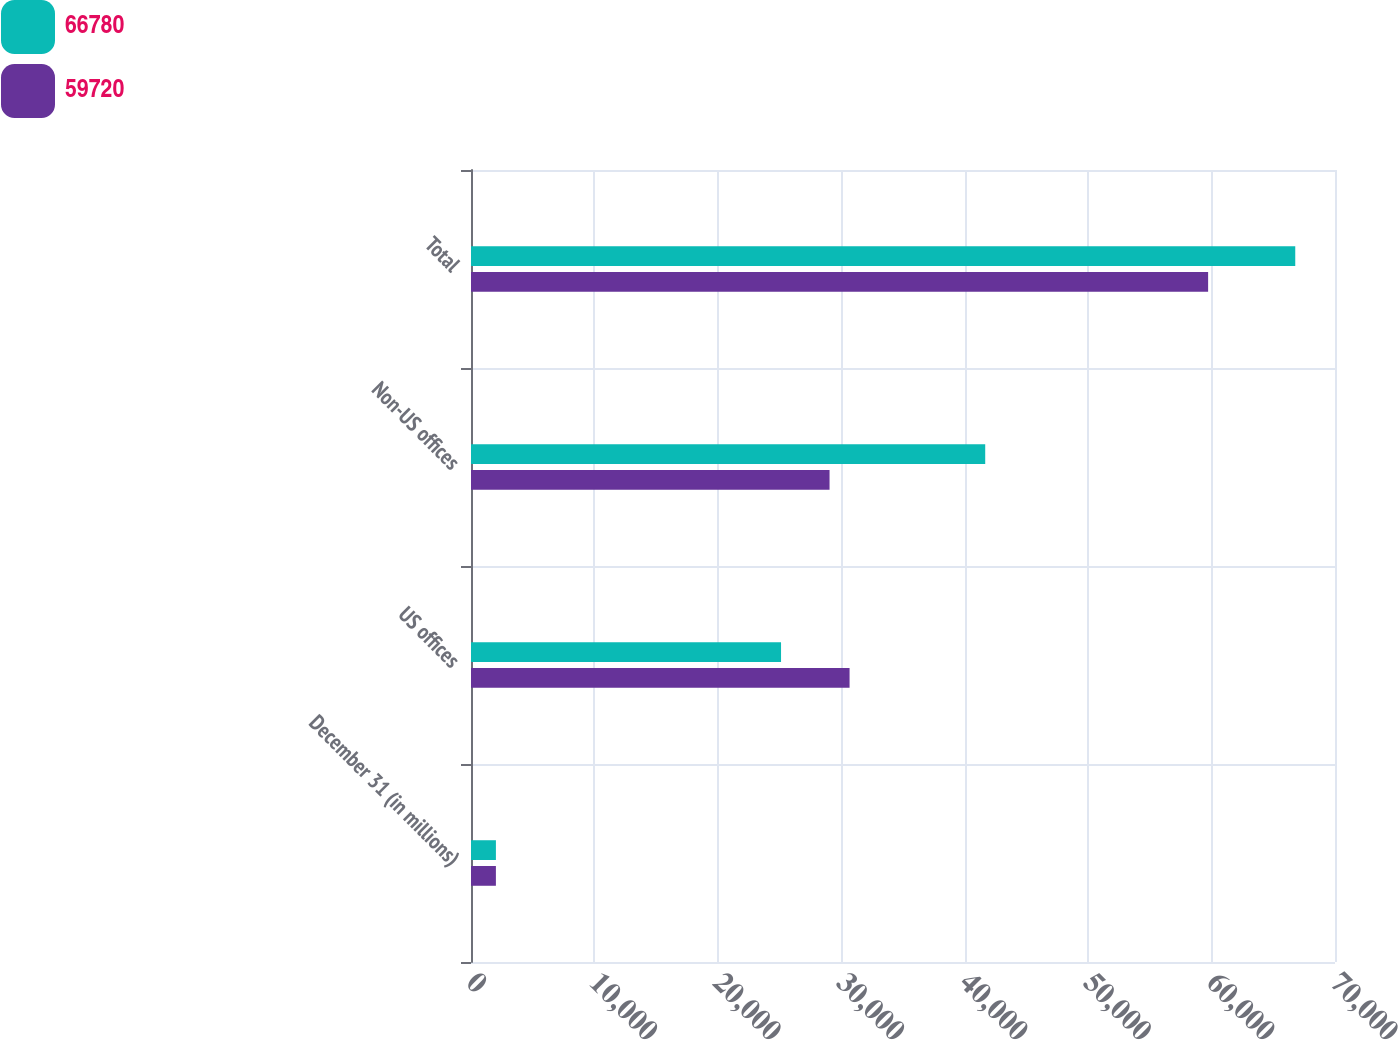Convert chart to OTSL. <chart><loc_0><loc_0><loc_500><loc_500><stacked_bar_chart><ecel><fcel>December 31 (in millions)<fcel>US offices<fcel>Non-US offices<fcel>Total<nl><fcel>66780<fcel>2018<fcel>25119<fcel>41661<fcel>66780<nl><fcel>59720<fcel>2017<fcel>30671<fcel>29049<fcel>59720<nl></chart> 